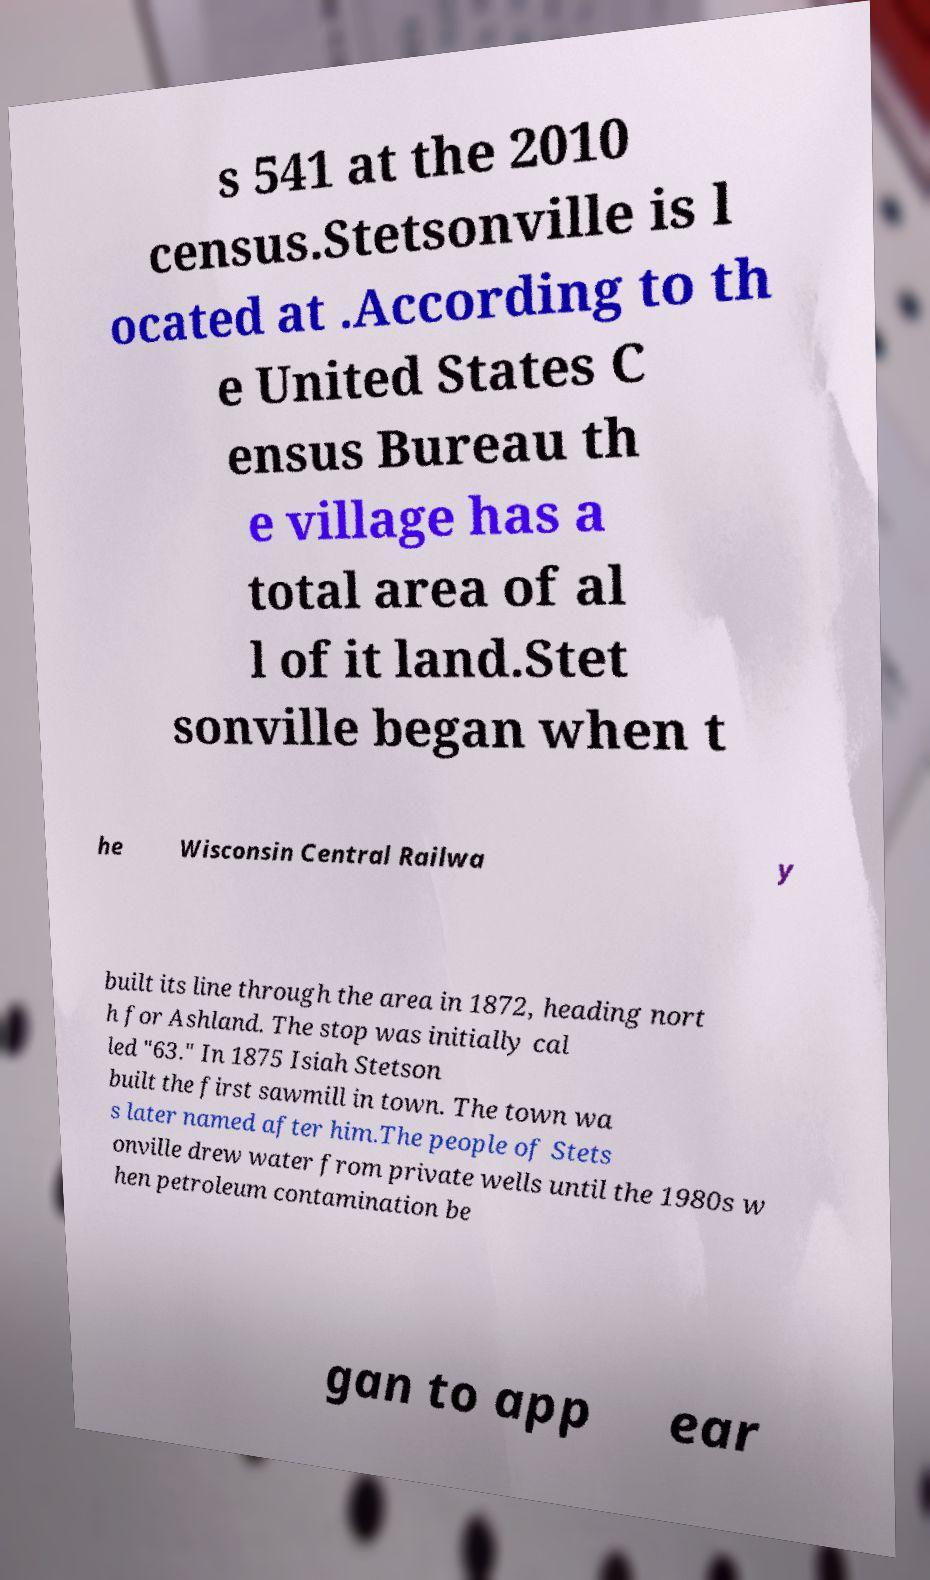I need the written content from this picture converted into text. Can you do that? s 541 at the 2010 census.Stetsonville is l ocated at .According to th e United States C ensus Bureau th e village has a total area of al l of it land.Stet sonville began when t he Wisconsin Central Railwa y built its line through the area in 1872, heading nort h for Ashland. The stop was initially cal led "63." In 1875 Isiah Stetson built the first sawmill in town. The town wa s later named after him.The people of Stets onville drew water from private wells until the 1980s w hen petroleum contamination be gan to app ear 